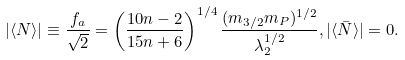Convert formula to latex. <formula><loc_0><loc_0><loc_500><loc_500>| \langle N \rangle | \equiv \frac { f _ { a } } { \sqrt { 2 } } = \left ( \frac { 1 0 n - 2 } { 1 5 n + 6 } \right ) ^ { 1 / 4 } \frac { ( m _ { 3 / 2 } m _ { P } ) ^ { 1 / 2 } } { \lambda _ { 2 } ^ { 1 / 2 } } , | \langle \bar { N } \rangle | = 0 .</formula> 